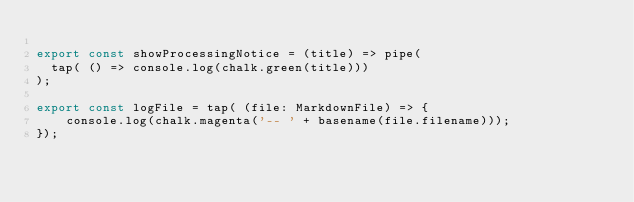Convert code to text. <code><loc_0><loc_0><loc_500><loc_500><_TypeScript_>
export const showProcessingNotice = (title) => pipe(
  tap( () => console.log(chalk.green(title)))
);

export const logFile = tap( (file: MarkdownFile) => {
    console.log(chalk.magenta('-- ' + basename(file.filename)));
});
</code> 